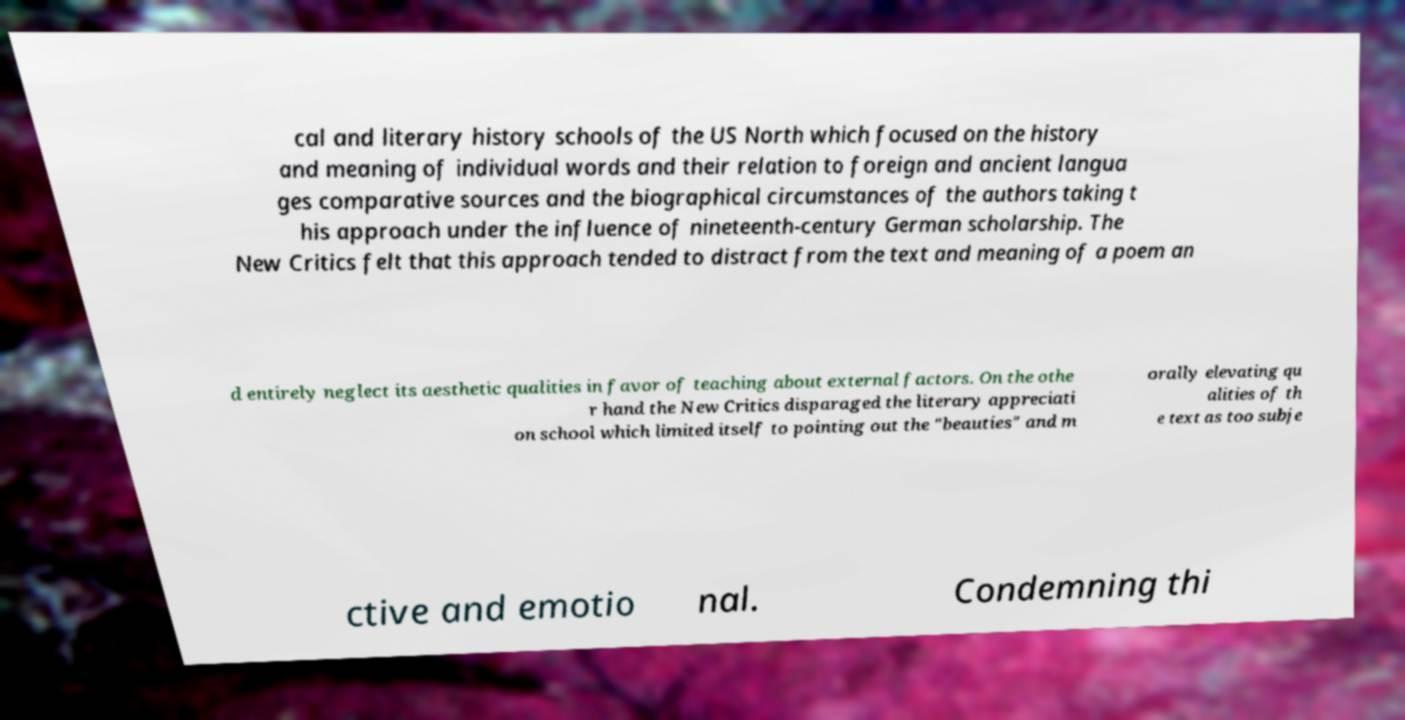Please read and relay the text visible in this image. What does it say? cal and literary history schools of the US North which focused on the history and meaning of individual words and their relation to foreign and ancient langua ges comparative sources and the biographical circumstances of the authors taking t his approach under the influence of nineteenth-century German scholarship. The New Critics felt that this approach tended to distract from the text and meaning of a poem an d entirely neglect its aesthetic qualities in favor of teaching about external factors. On the othe r hand the New Critics disparaged the literary appreciati on school which limited itself to pointing out the "beauties" and m orally elevating qu alities of th e text as too subje ctive and emotio nal. Condemning thi 